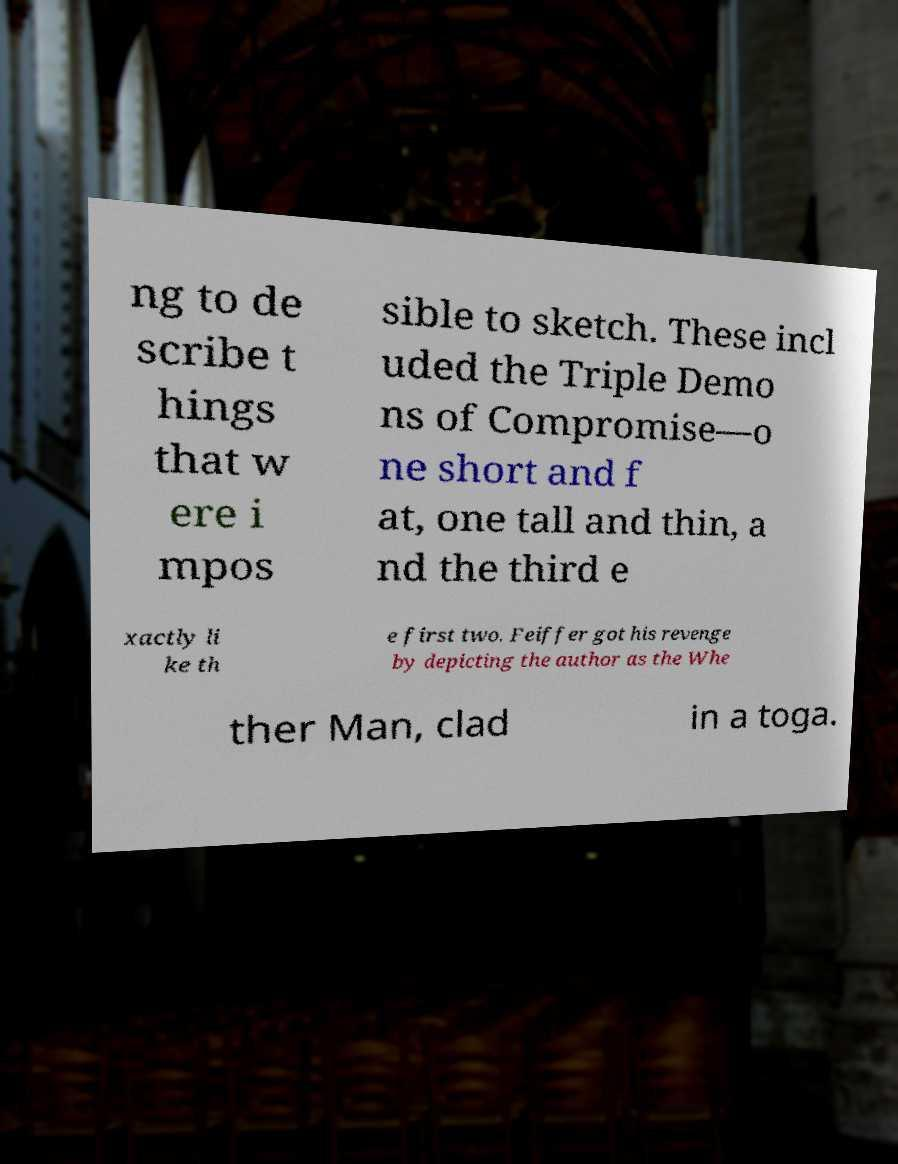Could you assist in decoding the text presented in this image and type it out clearly? ng to de scribe t hings that w ere i mpos sible to sketch. These incl uded the Triple Demo ns of Compromise—o ne short and f at, one tall and thin, a nd the third e xactly li ke th e first two. Feiffer got his revenge by depicting the author as the Whe ther Man, clad in a toga. 